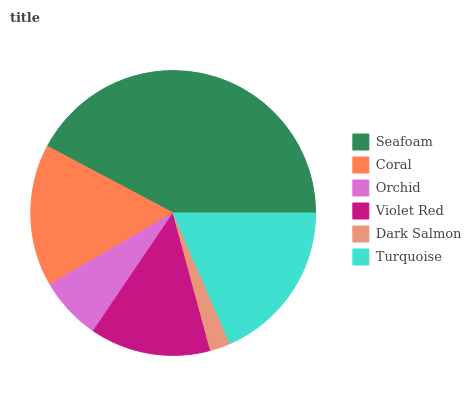Is Dark Salmon the minimum?
Answer yes or no. Yes. Is Seafoam the maximum?
Answer yes or no. Yes. Is Coral the minimum?
Answer yes or no. No. Is Coral the maximum?
Answer yes or no. No. Is Seafoam greater than Coral?
Answer yes or no. Yes. Is Coral less than Seafoam?
Answer yes or no. Yes. Is Coral greater than Seafoam?
Answer yes or no. No. Is Seafoam less than Coral?
Answer yes or no. No. Is Coral the high median?
Answer yes or no. Yes. Is Violet Red the low median?
Answer yes or no. Yes. Is Orchid the high median?
Answer yes or no. No. Is Turquoise the low median?
Answer yes or no. No. 